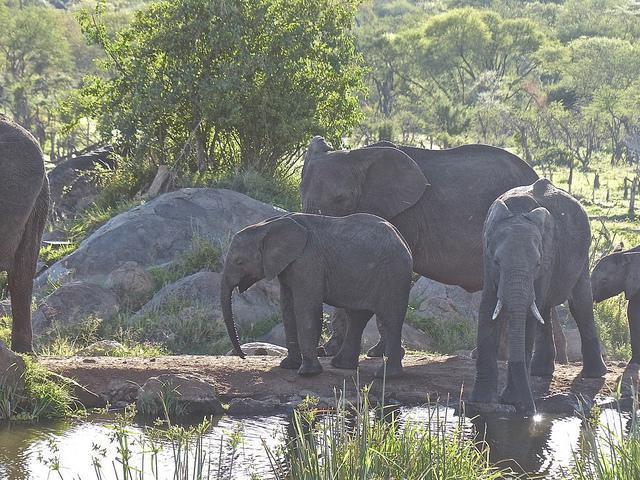How many elephants are there?
Give a very brief answer. 5. How many toothbrushes are there?
Give a very brief answer. 0. 